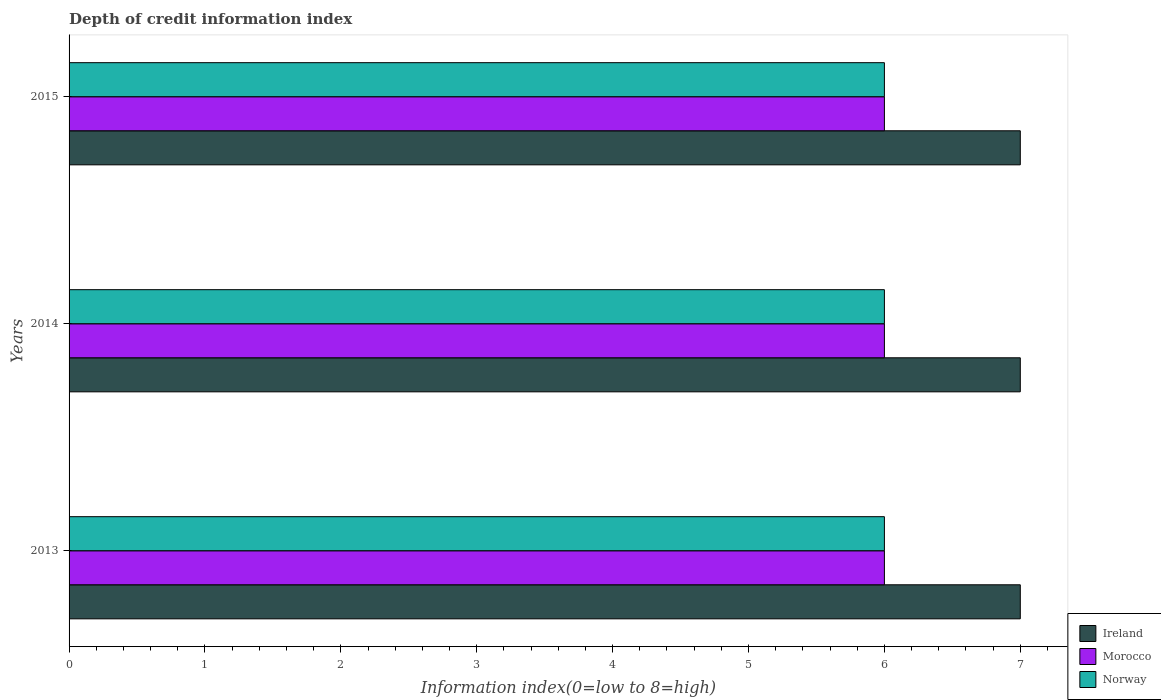How many different coloured bars are there?
Your answer should be very brief. 3. Are the number of bars per tick equal to the number of legend labels?
Your response must be concise. Yes. In how many cases, is the number of bars for a given year not equal to the number of legend labels?
Your answer should be very brief. 0. What is the information index in Ireland in 2015?
Offer a terse response. 7. Across all years, what is the maximum information index in Ireland?
Your answer should be compact. 7. Across all years, what is the minimum information index in Morocco?
Your answer should be compact. 6. In which year was the information index in Morocco maximum?
Ensure brevity in your answer.  2013. What is the total information index in Morocco in the graph?
Your answer should be compact. 18. What is the difference between the information index in Morocco in 2014 and that in 2015?
Your answer should be very brief. 0. What is the difference between the information index in Morocco in 2013 and the information index in Norway in 2015?
Keep it short and to the point. 0. In the year 2014, what is the difference between the information index in Norway and information index in Morocco?
Provide a short and direct response. 0. In how many years, is the information index in Norway greater than 5.6 ?
Provide a succinct answer. 3. Is the information index in Norway in 2013 less than that in 2015?
Offer a terse response. No. Is the difference between the information index in Norway in 2014 and 2015 greater than the difference between the information index in Morocco in 2014 and 2015?
Give a very brief answer. No. What is the difference between the highest and the second highest information index in Ireland?
Provide a short and direct response. 0. What does the 3rd bar from the top in 2014 represents?
Offer a very short reply. Ireland. How many bars are there?
Provide a short and direct response. 9. Are all the bars in the graph horizontal?
Keep it short and to the point. Yes. What is the difference between two consecutive major ticks on the X-axis?
Your answer should be compact. 1. Are the values on the major ticks of X-axis written in scientific E-notation?
Ensure brevity in your answer.  No. Does the graph contain any zero values?
Offer a very short reply. No. Does the graph contain grids?
Your answer should be very brief. No. Where does the legend appear in the graph?
Your answer should be compact. Bottom right. What is the title of the graph?
Offer a terse response. Depth of credit information index. What is the label or title of the X-axis?
Keep it short and to the point. Information index(0=low to 8=high). What is the label or title of the Y-axis?
Your answer should be very brief. Years. What is the Information index(0=low to 8=high) in Ireland in 2014?
Give a very brief answer. 7. What is the Information index(0=low to 8=high) in Morocco in 2014?
Ensure brevity in your answer.  6. What is the Information index(0=low to 8=high) of Ireland in 2015?
Ensure brevity in your answer.  7. What is the Information index(0=low to 8=high) of Morocco in 2015?
Keep it short and to the point. 6. What is the Information index(0=low to 8=high) in Norway in 2015?
Make the answer very short. 6. Across all years, what is the maximum Information index(0=low to 8=high) of Ireland?
Your answer should be very brief. 7. Across all years, what is the maximum Information index(0=low to 8=high) of Morocco?
Keep it short and to the point. 6. Across all years, what is the minimum Information index(0=low to 8=high) in Ireland?
Offer a very short reply. 7. Across all years, what is the minimum Information index(0=low to 8=high) in Morocco?
Your answer should be compact. 6. Across all years, what is the minimum Information index(0=low to 8=high) in Norway?
Offer a terse response. 6. What is the total Information index(0=low to 8=high) in Morocco in the graph?
Your response must be concise. 18. What is the difference between the Information index(0=low to 8=high) in Morocco in 2013 and that in 2014?
Offer a very short reply. 0. What is the difference between the Information index(0=low to 8=high) in Morocco in 2014 and that in 2015?
Offer a very short reply. 0. What is the difference between the Information index(0=low to 8=high) of Morocco in 2013 and the Information index(0=low to 8=high) of Norway in 2014?
Your response must be concise. 0. What is the difference between the Information index(0=low to 8=high) of Ireland in 2013 and the Information index(0=low to 8=high) of Morocco in 2015?
Provide a short and direct response. 1. What is the difference between the Information index(0=low to 8=high) of Ireland in 2013 and the Information index(0=low to 8=high) of Norway in 2015?
Give a very brief answer. 1. What is the difference between the Information index(0=low to 8=high) in Ireland in 2014 and the Information index(0=low to 8=high) in Morocco in 2015?
Keep it short and to the point. 1. What is the difference between the Information index(0=low to 8=high) in Morocco in 2014 and the Information index(0=low to 8=high) in Norway in 2015?
Provide a succinct answer. 0. What is the average Information index(0=low to 8=high) of Ireland per year?
Make the answer very short. 7. In the year 2013, what is the difference between the Information index(0=low to 8=high) of Ireland and Information index(0=low to 8=high) of Morocco?
Offer a terse response. 1. In the year 2013, what is the difference between the Information index(0=low to 8=high) in Ireland and Information index(0=low to 8=high) in Norway?
Provide a succinct answer. 1. In the year 2013, what is the difference between the Information index(0=low to 8=high) in Morocco and Information index(0=low to 8=high) in Norway?
Offer a very short reply. 0. In the year 2014, what is the difference between the Information index(0=low to 8=high) in Ireland and Information index(0=low to 8=high) in Morocco?
Keep it short and to the point. 1. In the year 2014, what is the difference between the Information index(0=low to 8=high) of Ireland and Information index(0=low to 8=high) of Norway?
Provide a short and direct response. 1. In the year 2015, what is the difference between the Information index(0=low to 8=high) of Ireland and Information index(0=low to 8=high) of Norway?
Your answer should be very brief. 1. In the year 2015, what is the difference between the Information index(0=low to 8=high) in Morocco and Information index(0=low to 8=high) in Norway?
Your answer should be very brief. 0. What is the ratio of the Information index(0=low to 8=high) in Norway in 2013 to that in 2014?
Offer a terse response. 1. What is the ratio of the Information index(0=low to 8=high) in Ireland in 2013 to that in 2015?
Offer a terse response. 1. What is the ratio of the Information index(0=low to 8=high) of Morocco in 2013 to that in 2015?
Your answer should be compact. 1. What is the ratio of the Information index(0=low to 8=high) of Ireland in 2014 to that in 2015?
Ensure brevity in your answer.  1. What is the ratio of the Information index(0=low to 8=high) in Morocco in 2014 to that in 2015?
Provide a short and direct response. 1. What is the ratio of the Information index(0=low to 8=high) in Norway in 2014 to that in 2015?
Your response must be concise. 1. 